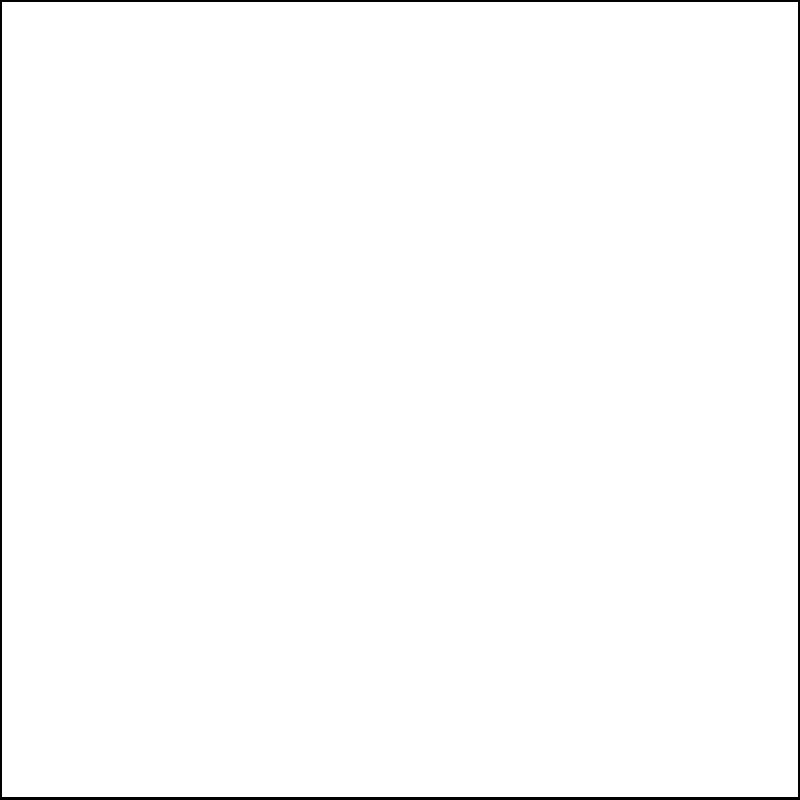In the coordinate system above, triangle ABC has been reflected across the x-axis to create triangle A'B'C'. As a guardian supporting students in geometry, how would you guide them to determine the coordinates of point C' after this reflection? To guide students in finding the coordinates of C' after reflection across the x-axis, we can follow these steps:

1. Identify the original coordinates of point C:
   C is located at (2, 3)

2. Explain the principle of reflection across the x-axis:
   When a point is reflected across the x-axis, its x-coordinate remains the same, but its y-coordinate changes sign (becomes negative).

3. Apply the reflection principle to point C:
   - The x-coordinate of C' will be the same as C: 2
   - The y-coordinate of C' will be the negative of C's y-coordinate: -3

4. Combine the new coordinates:
   C' will be at (2, -3)

5. Verify visually:
   We can see in the diagram that C' is indeed located at (2, -3)

By guiding students through this process, we help them understand the concept of reflection and how it affects coordinates, rather than simply giving them the answer.
Answer: (2, -3) 